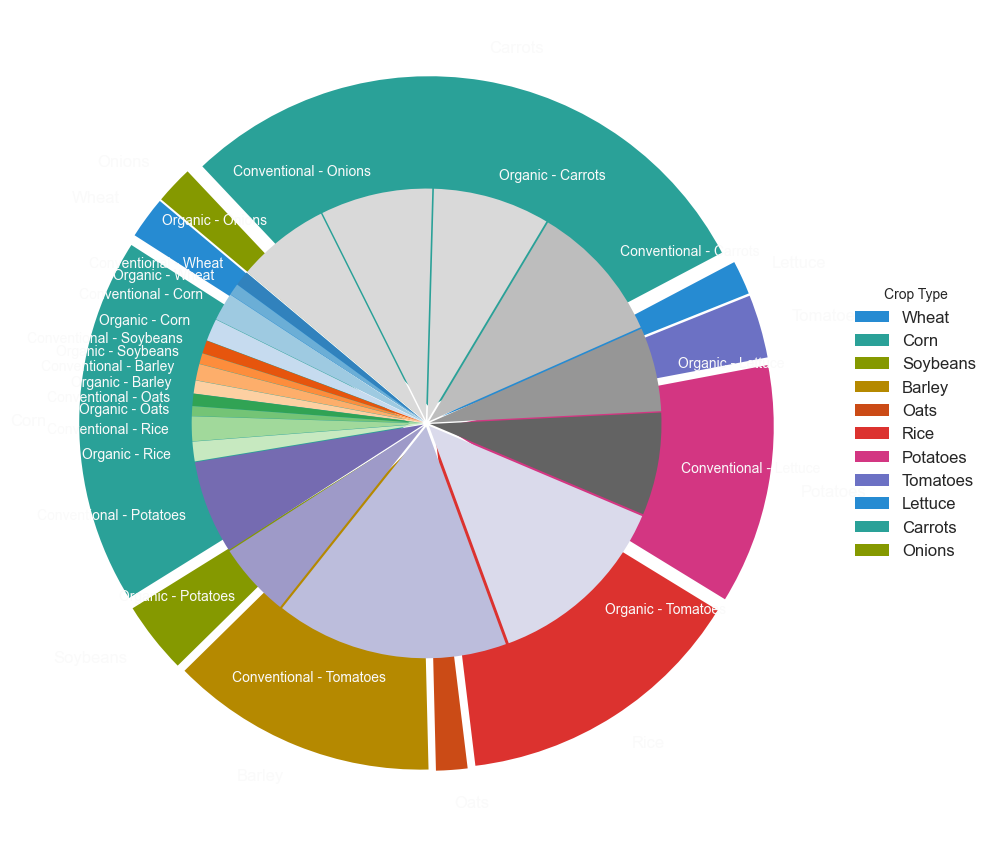Which crop type has the highest overall yield? By looking at the outer pie chart which represents the total yield for each crop type, the largest segment belongs to Tomatoes, indicating they have the highest overall yield.
Answer: Tomatoes Which crop type has the lowest overall yield? The smallest segment in the outer pie chart represents Oats, thus indicating Oats have the lowest overall yield.
Answer: Oats What is the yield difference between conventional and organic Tomatoes? According to the inner pie chart, conventional Tomatoes yield is 50.0 tons/hectare and organic Tomatoes yield is 40.0 tons/hectare. The difference is: 50.0 - 40.0 = 10.0 tons/hectare
Answer: 10.0 tons/hectare How much greater is the yield of conventional Potatoes compared to organic Potatoes? Interior segments show that conventional Potatoes yield is 20.0 tons/hectare while organic Potatoes yield is 16.0 tons/hectare. The difference is: 20.0 - 16.0 = 4.0 tons/hectare
Answer: 4.0 tons/hectare Which conventional practice crop has the highest yield? The largest inside segment for the "Conventional" practice is for Tomatoes, indicating the highest yield among conventional crops.
Answer: Tomatoes Is the yield of conventional Rice greater than that of organic Corn? Yes, by referring to the inner segments, conventional Rice yield (5.3 tons/hectare) is greater than organic Corn yield (4.8 tons/hectare).
Answer: Yes What is the total yield for both conventional and organic practices of Wheat? Adding the yields for Wheat: conventional (3.2 tons/hectare) and organic (2.5 tons/hectare), the result is: 3.2 + 2.5 = 5.7 tons/hectare
Answer: 5.7 tons/hectare Which crop transitions from conventional to organic practices experiences the largest drop in yield? Comparing all inner segments for yield differences when transitioning from conventional to organic, Tomatoes show the largest drop: 50.0 - 40.0 = 10.0 tons/hectare
Answer: Tomatoes Is the total yield of conventional practices for Corn greater than the combined organic yields of Barley and Carrots? Conventional Corn yield is 6.0 tons/hectare. Adding organic yields of Barley (2.8 tons/hectare) and Carrots (25.0 tons/hectare) the result is: 2.8 + 25.0 = 27.8 tons/hectare, which is greater than Corn's conventional yield.
Answer: No, the combined yields are greater Which yields more, organic Potatoes or conventional Lettuce? Comparing inner segments, organic Potatoes yield 16.0 tons/hectare and conventional Lettuce yield 22.0 tons/hectare. Conventional Lettuce yields more.
Answer: Conventional Lettuce 